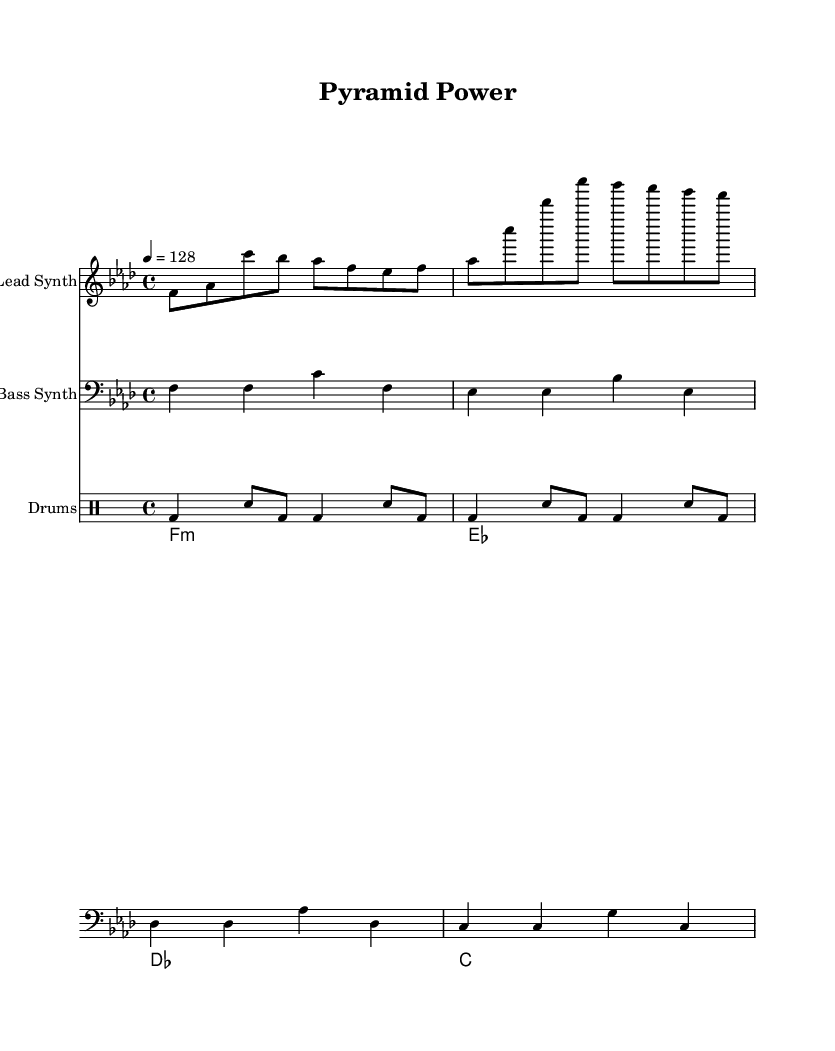What is the key signature of this music? The key signature shows one flat, which indicates that the piece is in F minor.
Answer: F minor What is the time signature of this music? The time signature is indicated by the "4/4" at the beginning of the piece, meaning there are 4 beats per measure.
Answer: 4/4 What is the tempo marking of this piece? The tempo marking is 128 beats per minute, indicated by "4 = 128" at the beginning of the score.
Answer: 128 How many measures are in the lead synth part? By counting the standard measures in the staff during the lead synth section, we see that there are 4 measures present.
Answer: 4 What type of chord is used in the pad synth? The pad synth uses a minor chord for the first chord, as indicated by "f1:m" which signifies that it is an F minor chord.
Answer: F minor How is the rhythm of the drum pattern structured? The drum pattern consists of a consistent kick drum (bd) and snare (sn) rhythm, alternating between quarter and eighth notes, emphasizing the upbeat feel.
Answer: Upbeat rhythm What is the bass synth note played in the first measure? The first note played in the bass synth part of the first measure is F.
Answer: F 